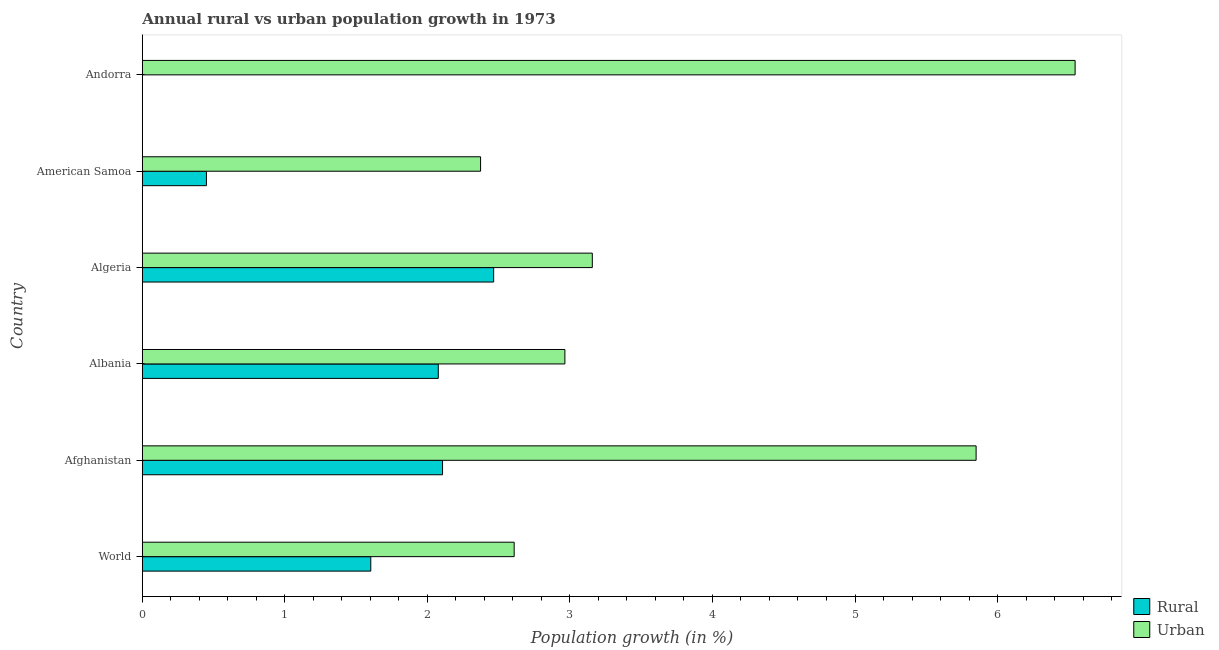Are the number of bars on each tick of the Y-axis equal?
Your answer should be very brief. No. How many bars are there on the 4th tick from the top?
Give a very brief answer. 2. How many bars are there on the 6th tick from the bottom?
Provide a succinct answer. 1. What is the label of the 1st group of bars from the top?
Offer a very short reply. Andorra. In how many cases, is the number of bars for a given country not equal to the number of legend labels?
Offer a very short reply. 1. What is the rural population growth in Algeria?
Give a very brief answer. 2.46. Across all countries, what is the maximum urban population growth?
Make the answer very short. 6.54. Across all countries, what is the minimum rural population growth?
Your answer should be very brief. 0. In which country was the urban population growth maximum?
Keep it short and to the point. Andorra. What is the total rural population growth in the graph?
Provide a short and direct response. 8.7. What is the difference between the urban population growth in Afghanistan and that in World?
Make the answer very short. 3.24. What is the difference between the urban population growth in Andorra and the rural population growth in American Samoa?
Keep it short and to the point. 6.09. What is the average rural population growth per country?
Provide a short and direct response. 1.45. What is the difference between the rural population growth and urban population growth in Afghanistan?
Your answer should be very brief. -3.74. In how many countries, is the urban population growth greater than 0.4 %?
Provide a succinct answer. 6. What is the ratio of the urban population growth in Algeria to that in American Samoa?
Provide a short and direct response. 1.33. What is the difference between the highest and the second highest rural population growth?
Provide a succinct answer. 0.36. What is the difference between the highest and the lowest rural population growth?
Your answer should be very brief. 2.46. In how many countries, is the rural population growth greater than the average rural population growth taken over all countries?
Your answer should be compact. 4. Is the sum of the urban population growth in Afghanistan and Algeria greater than the maximum rural population growth across all countries?
Offer a very short reply. Yes. How many bars are there?
Make the answer very short. 11. How many countries are there in the graph?
Keep it short and to the point. 6. What is the difference between two consecutive major ticks on the X-axis?
Your response must be concise. 1. Are the values on the major ticks of X-axis written in scientific E-notation?
Your answer should be compact. No. How are the legend labels stacked?
Keep it short and to the point. Vertical. What is the title of the graph?
Keep it short and to the point. Annual rural vs urban population growth in 1973. Does "Personal remittances" appear as one of the legend labels in the graph?
Provide a short and direct response. No. What is the label or title of the X-axis?
Provide a succinct answer. Population growth (in %). What is the Population growth (in %) of Rural in World?
Keep it short and to the point. 1.6. What is the Population growth (in %) in Urban  in World?
Give a very brief answer. 2.61. What is the Population growth (in %) of Rural in Afghanistan?
Make the answer very short. 2.11. What is the Population growth (in %) of Urban  in Afghanistan?
Provide a short and direct response. 5.85. What is the Population growth (in %) of Rural in Albania?
Keep it short and to the point. 2.08. What is the Population growth (in %) in Urban  in Albania?
Keep it short and to the point. 2.96. What is the Population growth (in %) in Rural in Algeria?
Make the answer very short. 2.46. What is the Population growth (in %) of Urban  in Algeria?
Offer a very short reply. 3.16. What is the Population growth (in %) of Rural in American Samoa?
Offer a terse response. 0.45. What is the Population growth (in %) of Urban  in American Samoa?
Keep it short and to the point. 2.37. What is the Population growth (in %) in Urban  in Andorra?
Provide a succinct answer. 6.54. Across all countries, what is the maximum Population growth (in %) in Rural?
Your response must be concise. 2.46. Across all countries, what is the maximum Population growth (in %) in Urban ?
Offer a very short reply. 6.54. Across all countries, what is the minimum Population growth (in %) of Urban ?
Keep it short and to the point. 2.37. What is the total Population growth (in %) in Rural in the graph?
Your answer should be compact. 8.7. What is the total Population growth (in %) of Urban  in the graph?
Give a very brief answer. 23.5. What is the difference between the Population growth (in %) in Rural in World and that in Afghanistan?
Provide a short and direct response. -0.5. What is the difference between the Population growth (in %) of Urban  in World and that in Afghanistan?
Provide a succinct answer. -3.24. What is the difference between the Population growth (in %) in Rural in World and that in Albania?
Provide a short and direct response. -0.47. What is the difference between the Population growth (in %) in Urban  in World and that in Albania?
Your response must be concise. -0.36. What is the difference between the Population growth (in %) in Rural in World and that in Algeria?
Ensure brevity in your answer.  -0.86. What is the difference between the Population growth (in %) in Urban  in World and that in Algeria?
Provide a short and direct response. -0.55. What is the difference between the Population growth (in %) in Rural in World and that in American Samoa?
Give a very brief answer. 1.15. What is the difference between the Population growth (in %) in Urban  in World and that in American Samoa?
Your answer should be very brief. 0.24. What is the difference between the Population growth (in %) of Urban  in World and that in Andorra?
Your response must be concise. -3.94. What is the difference between the Population growth (in %) of Rural in Afghanistan and that in Albania?
Your answer should be very brief. 0.03. What is the difference between the Population growth (in %) in Urban  in Afghanistan and that in Albania?
Provide a succinct answer. 2.89. What is the difference between the Population growth (in %) of Rural in Afghanistan and that in Algeria?
Offer a terse response. -0.36. What is the difference between the Population growth (in %) in Urban  in Afghanistan and that in Algeria?
Your response must be concise. 2.69. What is the difference between the Population growth (in %) of Rural in Afghanistan and that in American Samoa?
Keep it short and to the point. 1.66. What is the difference between the Population growth (in %) of Urban  in Afghanistan and that in American Samoa?
Offer a terse response. 3.48. What is the difference between the Population growth (in %) of Urban  in Afghanistan and that in Andorra?
Your answer should be compact. -0.69. What is the difference between the Population growth (in %) of Rural in Albania and that in Algeria?
Offer a very short reply. -0.39. What is the difference between the Population growth (in %) of Urban  in Albania and that in Algeria?
Offer a terse response. -0.19. What is the difference between the Population growth (in %) of Rural in Albania and that in American Samoa?
Your response must be concise. 1.63. What is the difference between the Population growth (in %) of Urban  in Albania and that in American Samoa?
Your response must be concise. 0.59. What is the difference between the Population growth (in %) in Urban  in Albania and that in Andorra?
Provide a succinct answer. -3.58. What is the difference between the Population growth (in %) of Rural in Algeria and that in American Samoa?
Your answer should be very brief. 2.02. What is the difference between the Population growth (in %) in Urban  in Algeria and that in American Samoa?
Your answer should be very brief. 0.78. What is the difference between the Population growth (in %) of Urban  in Algeria and that in Andorra?
Provide a short and direct response. -3.39. What is the difference between the Population growth (in %) in Urban  in American Samoa and that in Andorra?
Your answer should be compact. -4.17. What is the difference between the Population growth (in %) of Rural in World and the Population growth (in %) of Urban  in Afghanistan?
Your answer should be very brief. -4.25. What is the difference between the Population growth (in %) of Rural in World and the Population growth (in %) of Urban  in Albania?
Ensure brevity in your answer.  -1.36. What is the difference between the Population growth (in %) in Rural in World and the Population growth (in %) in Urban  in Algeria?
Make the answer very short. -1.55. What is the difference between the Population growth (in %) of Rural in World and the Population growth (in %) of Urban  in American Samoa?
Make the answer very short. -0.77. What is the difference between the Population growth (in %) of Rural in World and the Population growth (in %) of Urban  in Andorra?
Keep it short and to the point. -4.94. What is the difference between the Population growth (in %) in Rural in Afghanistan and the Population growth (in %) in Urban  in Albania?
Ensure brevity in your answer.  -0.86. What is the difference between the Population growth (in %) of Rural in Afghanistan and the Population growth (in %) of Urban  in Algeria?
Provide a succinct answer. -1.05. What is the difference between the Population growth (in %) in Rural in Afghanistan and the Population growth (in %) in Urban  in American Samoa?
Offer a very short reply. -0.27. What is the difference between the Population growth (in %) of Rural in Afghanistan and the Population growth (in %) of Urban  in Andorra?
Keep it short and to the point. -4.44. What is the difference between the Population growth (in %) of Rural in Albania and the Population growth (in %) of Urban  in Algeria?
Offer a terse response. -1.08. What is the difference between the Population growth (in %) of Rural in Albania and the Population growth (in %) of Urban  in American Samoa?
Give a very brief answer. -0.3. What is the difference between the Population growth (in %) in Rural in Albania and the Population growth (in %) in Urban  in Andorra?
Offer a very short reply. -4.47. What is the difference between the Population growth (in %) of Rural in Algeria and the Population growth (in %) of Urban  in American Samoa?
Your response must be concise. 0.09. What is the difference between the Population growth (in %) of Rural in Algeria and the Population growth (in %) of Urban  in Andorra?
Make the answer very short. -4.08. What is the difference between the Population growth (in %) of Rural in American Samoa and the Population growth (in %) of Urban  in Andorra?
Offer a terse response. -6.09. What is the average Population growth (in %) in Rural per country?
Your answer should be compact. 1.45. What is the average Population growth (in %) of Urban  per country?
Make the answer very short. 3.92. What is the difference between the Population growth (in %) of Rural and Population growth (in %) of Urban  in World?
Offer a terse response. -1.01. What is the difference between the Population growth (in %) in Rural and Population growth (in %) in Urban  in Afghanistan?
Make the answer very short. -3.74. What is the difference between the Population growth (in %) of Rural and Population growth (in %) of Urban  in Albania?
Make the answer very short. -0.89. What is the difference between the Population growth (in %) in Rural and Population growth (in %) in Urban  in Algeria?
Your answer should be very brief. -0.69. What is the difference between the Population growth (in %) of Rural and Population growth (in %) of Urban  in American Samoa?
Provide a succinct answer. -1.92. What is the ratio of the Population growth (in %) of Rural in World to that in Afghanistan?
Make the answer very short. 0.76. What is the ratio of the Population growth (in %) in Urban  in World to that in Afghanistan?
Provide a short and direct response. 0.45. What is the ratio of the Population growth (in %) of Rural in World to that in Albania?
Your response must be concise. 0.77. What is the ratio of the Population growth (in %) in Urban  in World to that in Albania?
Your answer should be very brief. 0.88. What is the ratio of the Population growth (in %) of Rural in World to that in Algeria?
Provide a succinct answer. 0.65. What is the ratio of the Population growth (in %) in Urban  in World to that in Algeria?
Give a very brief answer. 0.83. What is the ratio of the Population growth (in %) in Rural in World to that in American Samoa?
Ensure brevity in your answer.  3.56. What is the ratio of the Population growth (in %) in Urban  in World to that in American Samoa?
Give a very brief answer. 1.1. What is the ratio of the Population growth (in %) in Urban  in World to that in Andorra?
Your response must be concise. 0.4. What is the ratio of the Population growth (in %) in Rural in Afghanistan to that in Albania?
Provide a succinct answer. 1.01. What is the ratio of the Population growth (in %) in Urban  in Afghanistan to that in Albania?
Your answer should be very brief. 1.97. What is the ratio of the Population growth (in %) in Rural in Afghanistan to that in Algeria?
Offer a terse response. 0.85. What is the ratio of the Population growth (in %) in Urban  in Afghanistan to that in Algeria?
Offer a terse response. 1.85. What is the ratio of the Population growth (in %) of Rural in Afghanistan to that in American Samoa?
Make the answer very short. 4.68. What is the ratio of the Population growth (in %) in Urban  in Afghanistan to that in American Samoa?
Offer a very short reply. 2.47. What is the ratio of the Population growth (in %) of Urban  in Afghanistan to that in Andorra?
Offer a very short reply. 0.89. What is the ratio of the Population growth (in %) in Rural in Albania to that in Algeria?
Your response must be concise. 0.84. What is the ratio of the Population growth (in %) in Urban  in Albania to that in Algeria?
Your response must be concise. 0.94. What is the ratio of the Population growth (in %) of Rural in Albania to that in American Samoa?
Offer a terse response. 4.62. What is the ratio of the Population growth (in %) in Urban  in Albania to that in American Samoa?
Offer a terse response. 1.25. What is the ratio of the Population growth (in %) of Urban  in Albania to that in Andorra?
Offer a very short reply. 0.45. What is the ratio of the Population growth (in %) in Rural in Algeria to that in American Samoa?
Offer a very short reply. 5.48. What is the ratio of the Population growth (in %) of Urban  in Algeria to that in American Samoa?
Offer a very short reply. 1.33. What is the ratio of the Population growth (in %) of Urban  in Algeria to that in Andorra?
Make the answer very short. 0.48. What is the ratio of the Population growth (in %) in Urban  in American Samoa to that in Andorra?
Provide a short and direct response. 0.36. What is the difference between the highest and the second highest Population growth (in %) of Rural?
Make the answer very short. 0.36. What is the difference between the highest and the second highest Population growth (in %) of Urban ?
Your response must be concise. 0.69. What is the difference between the highest and the lowest Population growth (in %) of Rural?
Make the answer very short. 2.46. What is the difference between the highest and the lowest Population growth (in %) in Urban ?
Make the answer very short. 4.17. 